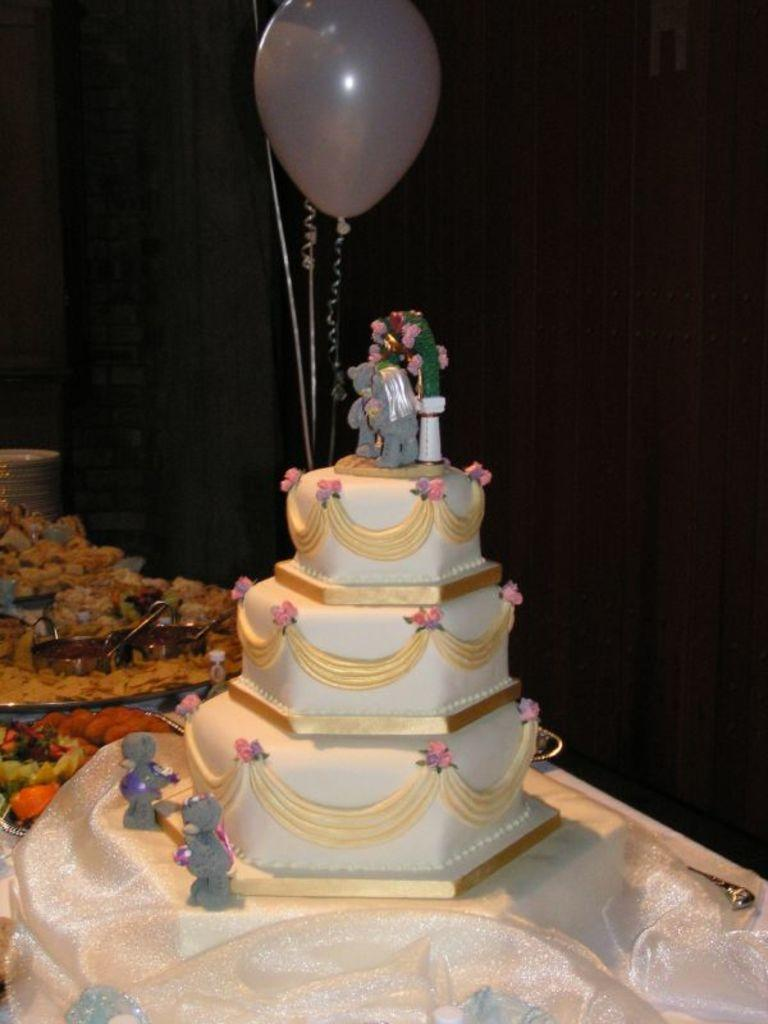What is the main subject in the middle of the image? There is a step cake in the middle of the image. What is located at the top of the image? There is a balloon at the top of the image. What decorations are on the cake? There are toys on the cake. What can be seen on the left side of the image? There are plates on the left side of the image. What is on the plates? There are food items on the plates. What type of statement can be seen on the cake? There is no statement visible on the cake; it is decorated with toys. What type of lettuce is used as a decoration on the cake? There is no lettuce present on the cake; it is decorated with toys. 